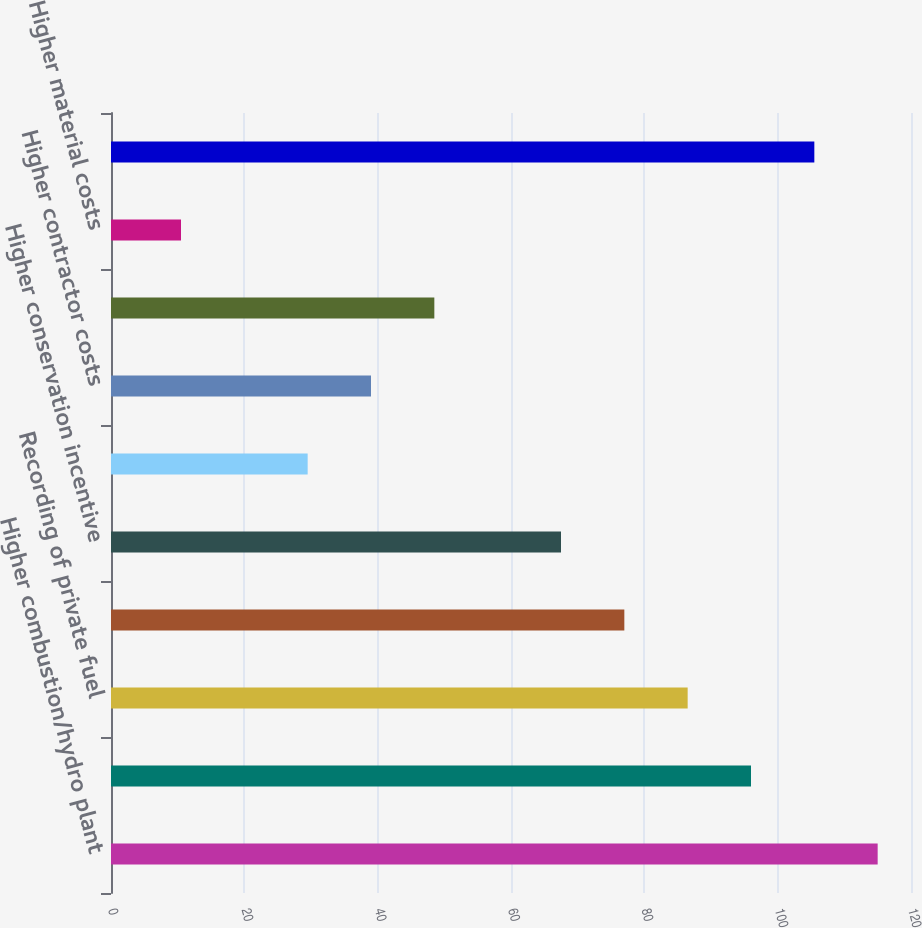Convert chart to OTSL. <chart><loc_0><loc_0><loc_500><loc_500><bar_chart><fcel>Higher combustion/hydro plant<fcel>Higher nuclear plant operation<fcel>Recording of private fuel<fcel>Higher labor costs<fcel>Higher conservation incentive<fcel>Lower gains/losses on sale or<fcel>Higher contractor costs<fcel>Higher donations including low<fcel>Higher material costs<fcel>Lower employee benefit costs<nl><fcel>115<fcel>96<fcel>86.5<fcel>77<fcel>67.5<fcel>29.5<fcel>39<fcel>48.5<fcel>10.5<fcel>105.5<nl></chart> 